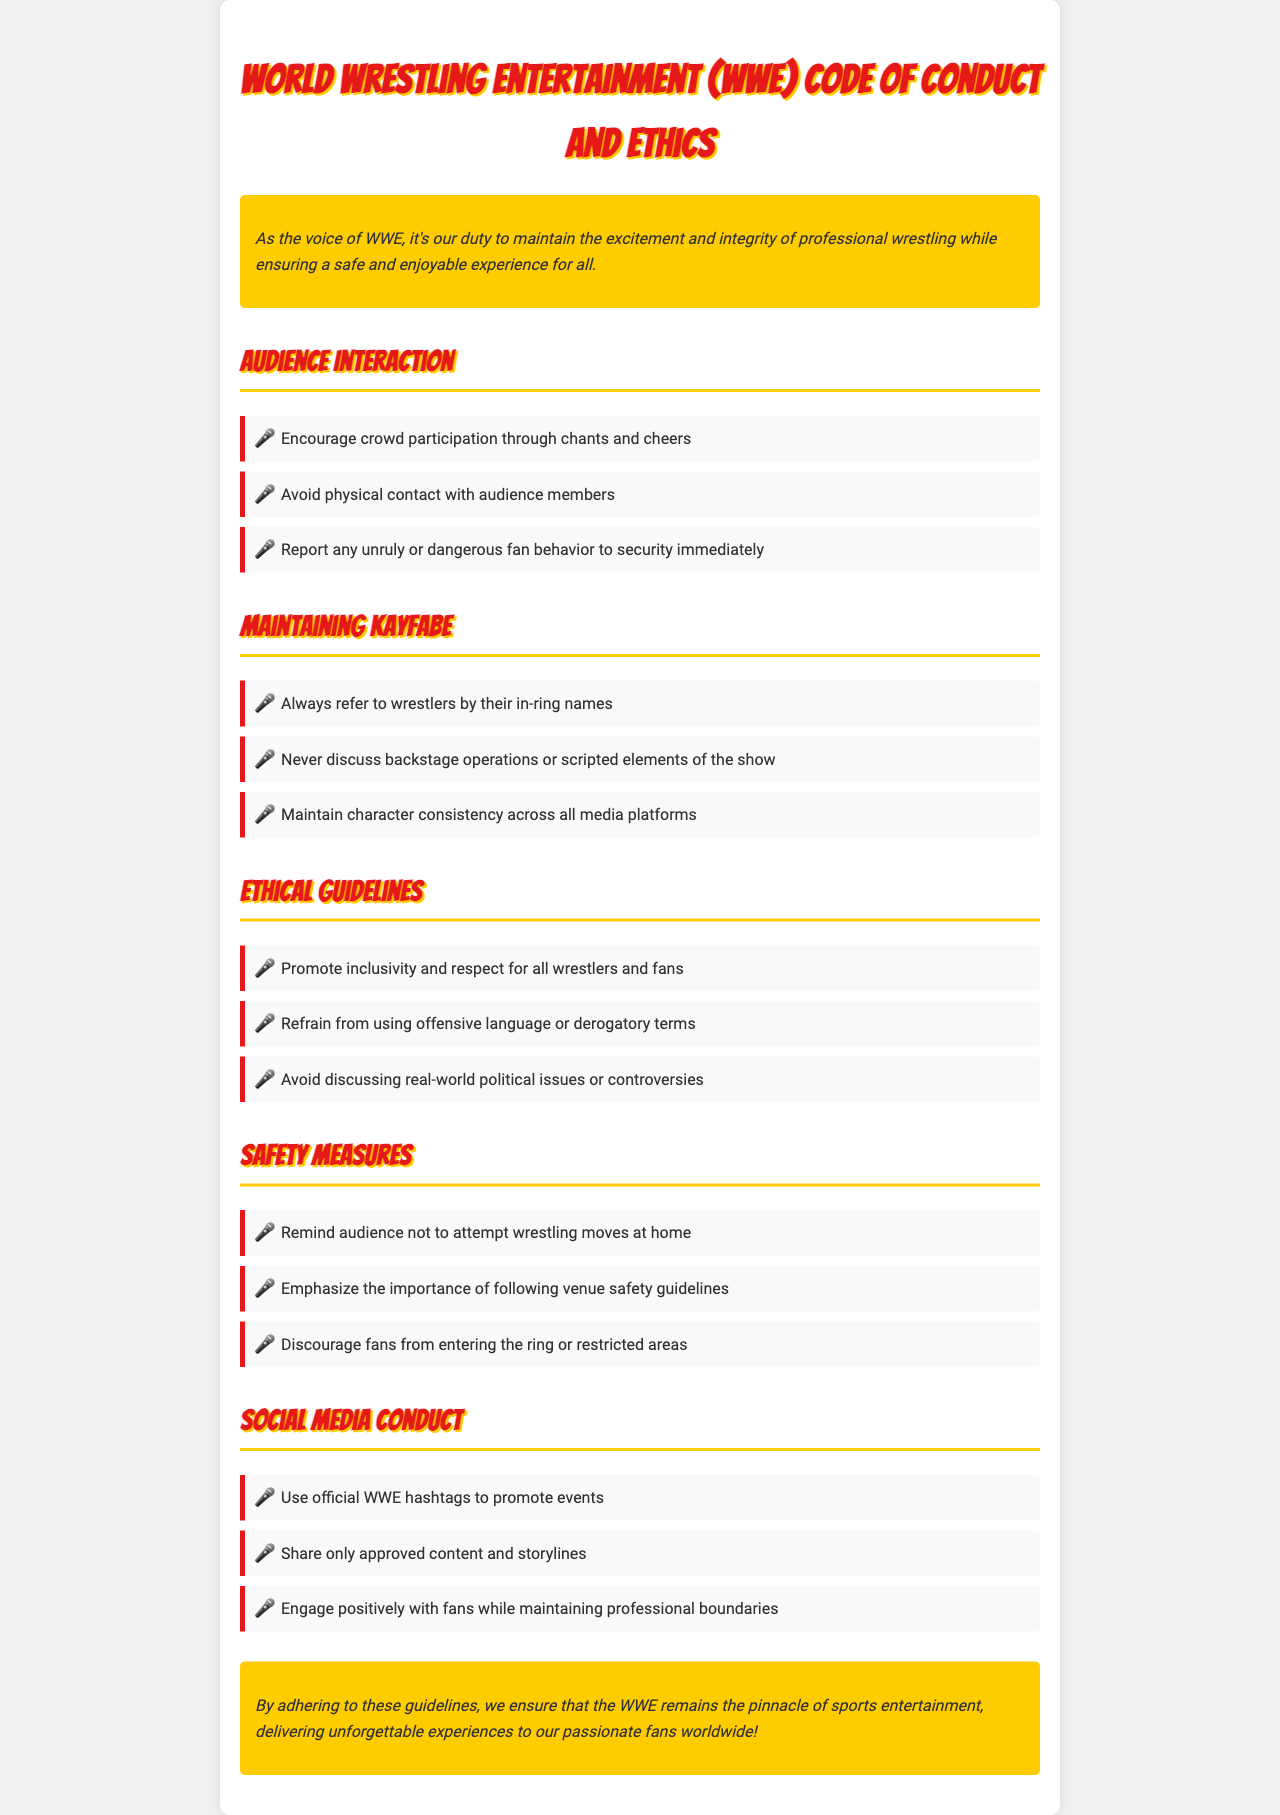What is the title of the document? The title is stated in the header of the document, which is "World Wrestling Entertainment (WWE) Code of Conduct and Ethics."
Answer: World Wrestling Entertainment (WWE) Code of Conduct and Ethics What should you avoid when interacting with the audience? The document lists specific guidelines for audience interaction, including one where it states to avoid physical contact with audience members.
Answer: Avoid physical contact What is the main purpose of the ethical guidelines? The ethical guidelines promote a positive environment among wrestlers and fans by emphasizing respect and inclusivity, avoiding offensive language, and steering clear of political issues.
Answer: Promote inclusivity and respect According to the document, what should you always refer to wrestlers by? The document specifically mentions that wrestlers should always be referred to by their in-ring names.
Answer: In-ring names What is one of the safety measures highlighted in the document? The document outlines the importance of reminding the audience not to attempt wrestling moves at home as a safety measure.
Answer: Not to attempt wrestling moves at home What does the document encourage regarding crowd participation? It encourages crowd participation through chants and cheers as noted in the guidelines for audience interaction.
Answer: Chants and cheers What is emphasized regarding social media conduct? The document highlights the need to use official WWE hashtags to promote events as a key point for social media conduct.
Answer: Use official WWE hashtags What is the closing message of the document? The closing message focuses on ensuring WWE delivers unforgettable experiences to fans worldwide by adhering to the guidelines.
Answer: Delivering unforgettable experiences 